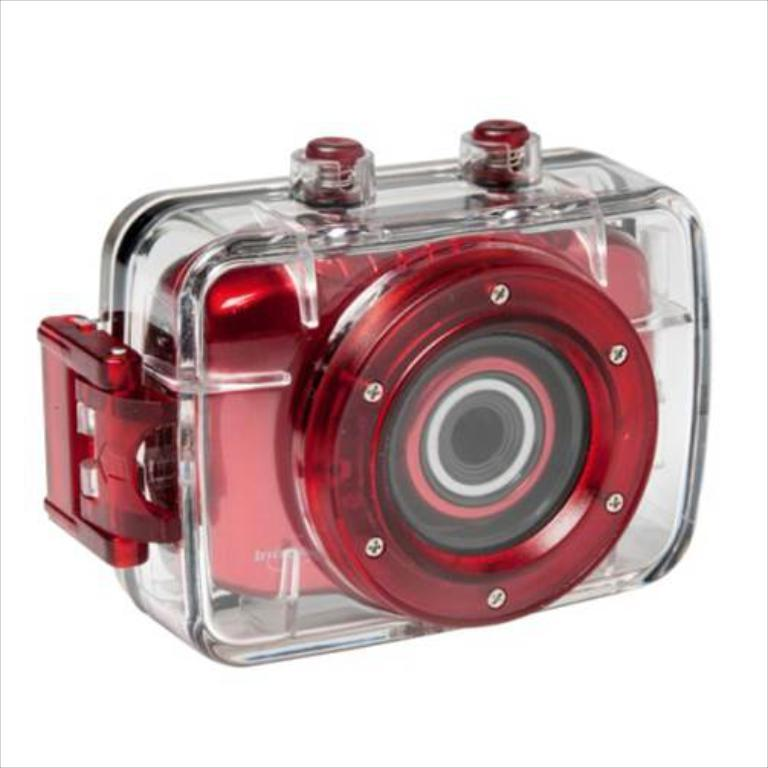What is the main object in the picture? There is a camera in the picture. What part of the camera is visible in the front? The camera has a lens in the front. What can be seen on the back of the camera? The camera has brightness visible in the back. What type of dirt can be seen on the camera lens in the image? There is no dirt visible on the camera lens in the image. Is there a committee meeting taking place in the image? There is no reference to a committee meeting in the image, as it features a camera with a lens and brightness visible. 